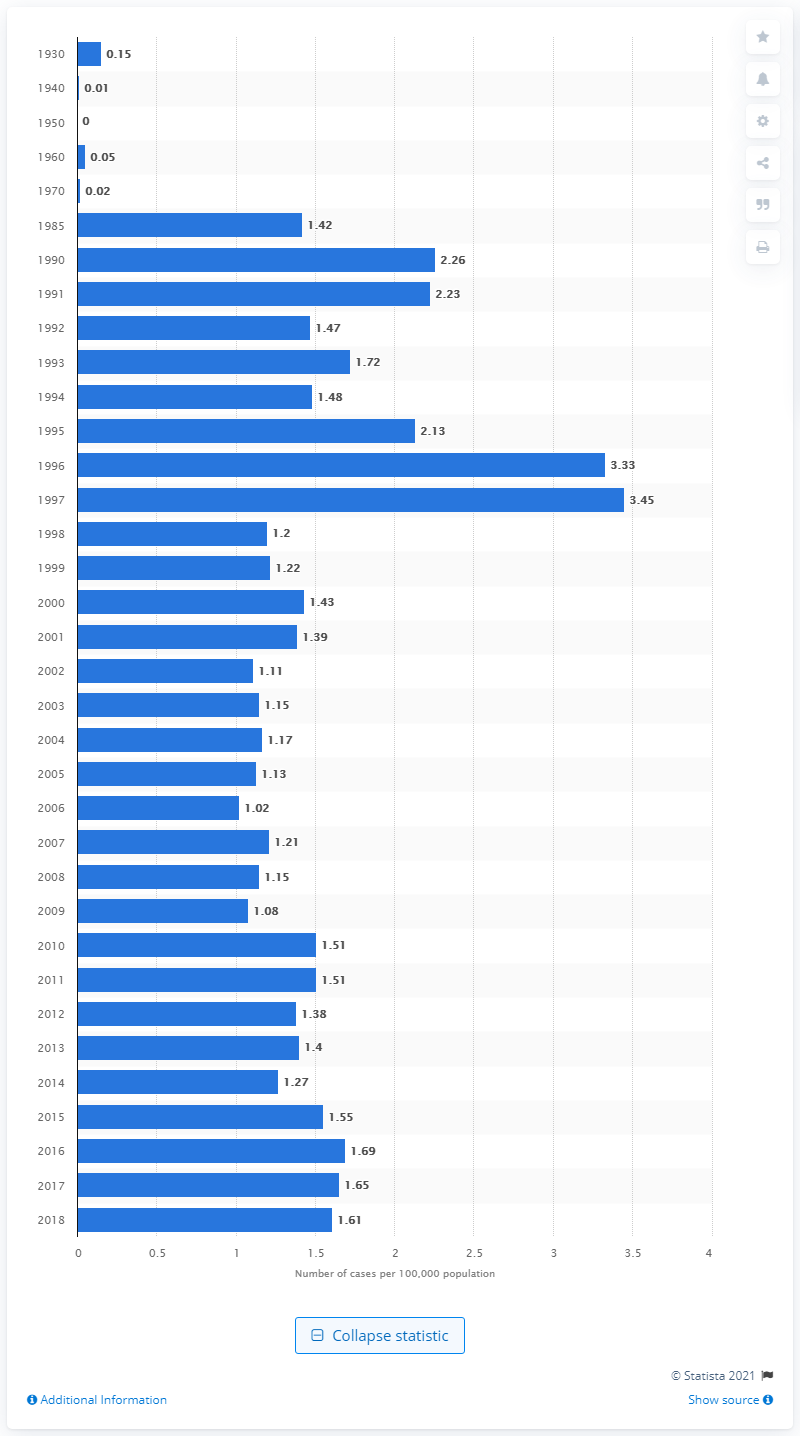Outline some significant characteristics in this image. In 1930, the reported rate of malaria per 100,000 people in Canada was 0.15. According to reported data, the rate of malaria in Canada in 2018 was 1.61. 